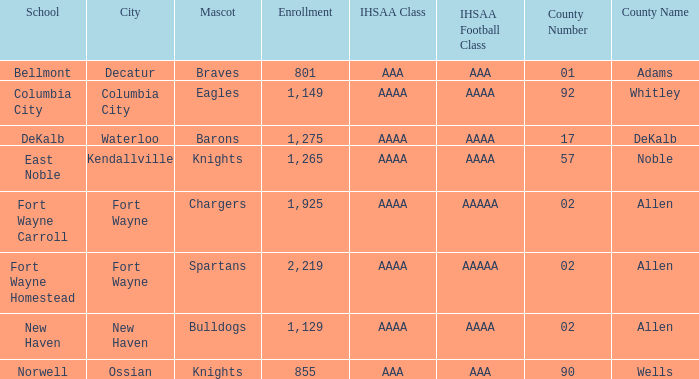What is the name of the school that has a spartan mascot, belongs to the aaaa ihsaa class, and has more than 1,275 students enrolled? Fort Wayne Homestead. 